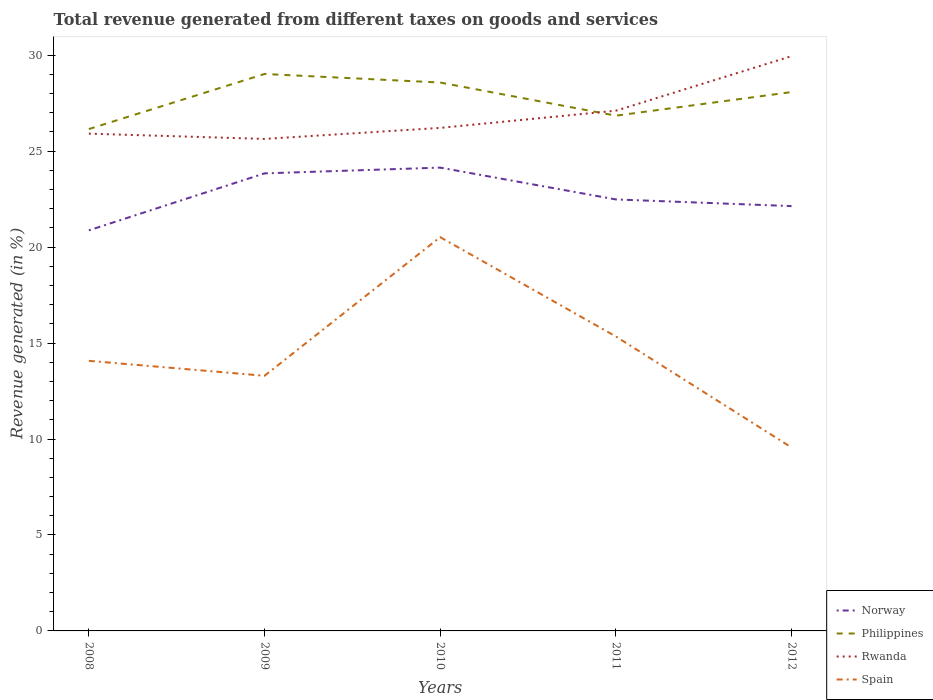Is the number of lines equal to the number of legend labels?
Give a very brief answer. Yes. Across all years, what is the maximum total revenue generated in Norway?
Provide a succinct answer. 20.87. In which year was the total revenue generated in Rwanda maximum?
Ensure brevity in your answer.  2009. What is the total total revenue generated in Norway in the graph?
Your answer should be very brief. -2.97. What is the difference between the highest and the second highest total revenue generated in Philippines?
Ensure brevity in your answer.  2.87. Is the total revenue generated in Philippines strictly greater than the total revenue generated in Rwanda over the years?
Offer a very short reply. No. How many years are there in the graph?
Your answer should be very brief. 5. What is the difference between two consecutive major ticks on the Y-axis?
Give a very brief answer. 5. Does the graph contain grids?
Provide a succinct answer. No. Where does the legend appear in the graph?
Provide a succinct answer. Bottom right. How many legend labels are there?
Make the answer very short. 4. What is the title of the graph?
Offer a terse response. Total revenue generated from different taxes on goods and services. Does "Slovak Republic" appear as one of the legend labels in the graph?
Give a very brief answer. No. What is the label or title of the X-axis?
Offer a terse response. Years. What is the label or title of the Y-axis?
Keep it short and to the point. Revenue generated (in %). What is the Revenue generated (in %) of Norway in 2008?
Your answer should be compact. 20.87. What is the Revenue generated (in %) of Philippines in 2008?
Offer a very short reply. 26.15. What is the Revenue generated (in %) in Rwanda in 2008?
Provide a succinct answer. 25.91. What is the Revenue generated (in %) of Spain in 2008?
Keep it short and to the point. 14.07. What is the Revenue generated (in %) of Norway in 2009?
Ensure brevity in your answer.  23.84. What is the Revenue generated (in %) in Philippines in 2009?
Give a very brief answer. 29.02. What is the Revenue generated (in %) of Rwanda in 2009?
Provide a short and direct response. 25.64. What is the Revenue generated (in %) in Spain in 2009?
Ensure brevity in your answer.  13.3. What is the Revenue generated (in %) of Norway in 2010?
Keep it short and to the point. 24.14. What is the Revenue generated (in %) of Philippines in 2010?
Your answer should be compact. 28.58. What is the Revenue generated (in %) of Rwanda in 2010?
Ensure brevity in your answer.  26.21. What is the Revenue generated (in %) in Spain in 2010?
Offer a very short reply. 20.52. What is the Revenue generated (in %) of Norway in 2011?
Provide a short and direct response. 22.48. What is the Revenue generated (in %) in Philippines in 2011?
Make the answer very short. 26.85. What is the Revenue generated (in %) in Rwanda in 2011?
Ensure brevity in your answer.  27.11. What is the Revenue generated (in %) of Spain in 2011?
Keep it short and to the point. 15.34. What is the Revenue generated (in %) in Norway in 2012?
Your response must be concise. 22.14. What is the Revenue generated (in %) in Philippines in 2012?
Your response must be concise. 28.08. What is the Revenue generated (in %) in Rwanda in 2012?
Offer a very short reply. 29.95. What is the Revenue generated (in %) in Spain in 2012?
Provide a short and direct response. 9.56. Across all years, what is the maximum Revenue generated (in %) of Norway?
Offer a very short reply. 24.14. Across all years, what is the maximum Revenue generated (in %) of Philippines?
Provide a succinct answer. 29.02. Across all years, what is the maximum Revenue generated (in %) in Rwanda?
Ensure brevity in your answer.  29.95. Across all years, what is the maximum Revenue generated (in %) in Spain?
Your answer should be compact. 20.52. Across all years, what is the minimum Revenue generated (in %) in Norway?
Provide a short and direct response. 20.87. Across all years, what is the minimum Revenue generated (in %) in Philippines?
Your response must be concise. 26.15. Across all years, what is the minimum Revenue generated (in %) in Rwanda?
Offer a very short reply. 25.64. Across all years, what is the minimum Revenue generated (in %) in Spain?
Your response must be concise. 9.56. What is the total Revenue generated (in %) in Norway in the graph?
Ensure brevity in your answer.  113.48. What is the total Revenue generated (in %) of Philippines in the graph?
Make the answer very short. 138.68. What is the total Revenue generated (in %) in Rwanda in the graph?
Your answer should be compact. 134.82. What is the total Revenue generated (in %) of Spain in the graph?
Ensure brevity in your answer.  72.79. What is the difference between the Revenue generated (in %) in Norway in 2008 and that in 2009?
Provide a succinct answer. -2.97. What is the difference between the Revenue generated (in %) of Philippines in 2008 and that in 2009?
Make the answer very short. -2.87. What is the difference between the Revenue generated (in %) in Rwanda in 2008 and that in 2009?
Your answer should be very brief. 0.27. What is the difference between the Revenue generated (in %) in Spain in 2008 and that in 2009?
Make the answer very short. 0.78. What is the difference between the Revenue generated (in %) of Norway in 2008 and that in 2010?
Your response must be concise. -3.27. What is the difference between the Revenue generated (in %) in Philippines in 2008 and that in 2010?
Provide a short and direct response. -2.42. What is the difference between the Revenue generated (in %) of Rwanda in 2008 and that in 2010?
Make the answer very short. -0.3. What is the difference between the Revenue generated (in %) in Spain in 2008 and that in 2010?
Give a very brief answer. -6.45. What is the difference between the Revenue generated (in %) in Norway in 2008 and that in 2011?
Make the answer very short. -1.61. What is the difference between the Revenue generated (in %) of Philippines in 2008 and that in 2011?
Offer a terse response. -0.7. What is the difference between the Revenue generated (in %) of Rwanda in 2008 and that in 2011?
Your response must be concise. -1.2. What is the difference between the Revenue generated (in %) in Spain in 2008 and that in 2011?
Keep it short and to the point. -1.27. What is the difference between the Revenue generated (in %) in Norway in 2008 and that in 2012?
Make the answer very short. -1.26. What is the difference between the Revenue generated (in %) of Philippines in 2008 and that in 2012?
Provide a short and direct response. -1.93. What is the difference between the Revenue generated (in %) in Rwanda in 2008 and that in 2012?
Ensure brevity in your answer.  -4.04. What is the difference between the Revenue generated (in %) in Spain in 2008 and that in 2012?
Your answer should be very brief. 4.51. What is the difference between the Revenue generated (in %) in Philippines in 2009 and that in 2010?
Offer a very short reply. 0.45. What is the difference between the Revenue generated (in %) in Rwanda in 2009 and that in 2010?
Your answer should be very brief. -0.57. What is the difference between the Revenue generated (in %) in Spain in 2009 and that in 2010?
Provide a succinct answer. -7.22. What is the difference between the Revenue generated (in %) in Norway in 2009 and that in 2011?
Give a very brief answer. 1.36. What is the difference between the Revenue generated (in %) in Philippines in 2009 and that in 2011?
Keep it short and to the point. 2.17. What is the difference between the Revenue generated (in %) in Rwanda in 2009 and that in 2011?
Give a very brief answer. -1.47. What is the difference between the Revenue generated (in %) in Spain in 2009 and that in 2011?
Offer a terse response. -2.05. What is the difference between the Revenue generated (in %) of Norway in 2009 and that in 2012?
Your answer should be compact. 1.71. What is the difference between the Revenue generated (in %) in Philippines in 2009 and that in 2012?
Offer a very short reply. 0.94. What is the difference between the Revenue generated (in %) in Rwanda in 2009 and that in 2012?
Offer a terse response. -4.31. What is the difference between the Revenue generated (in %) in Spain in 2009 and that in 2012?
Give a very brief answer. 3.74. What is the difference between the Revenue generated (in %) in Norway in 2010 and that in 2011?
Make the answer very short. 1.66. What is the difference between the Revenue generated (in %) of Philippines in 2010 and that in 2011?
Your answer should be compact. 1.73. What is the difference between the Revenue generated (in %) in Rwanda in 2010 and that in 2011?
Offer a terse response. -0.9. What is the difference between the Revenue generated (in %) in Spain in 2010 and that in 2011?
Provide a short and direct response. 5.17. What is the difference between the Revenue generated (in %) in Norway in 2010 and that in 2012?
Provide a short and direct response. 2.01. What is the difference between the Revenue generated (in %) in Philippines in 2010 and that in 2012?
Offer a very short reply. 0.5. What is the difference between the Revenue generated (in %) of Rwanda in 2010 and that in 2012?
Offer a very short reply. -3.74. What is the difference between the Revenue generated (in %) in Spain in 2010 and that in 2012?
Provide a short and direct response. 10.96. What is the difference between the Revenue generated (in %) of Norway in 2011 and that in 2012?
Provide a short and direct response. 0.35. What is the difference between the Revenue generated (in %) in Philippines in 2011 and that in 2012?
Keep it short and to the point. -1.23. What is the difference between the Revenue generated (in %) in Rwanda in 2011 and that in 2012?
Your response must be concise. -2.84. What is the difference between the Revenue generated (in %) in Spain in 2011 and that in 2012?
Give a very brief answer. 5.78. What is the difference between the Revenue generated (in %) in Norway in 2008 and the Revenue generated (in %) in Philippines in 2009?
Your response must be concise. -8.15. What is the difference between the Revenue generated (in %) in Norway in 2008 and the Revenue generated (in %) in Rwanda in 2009?
Offer a terse response. -4.76. What is the difference between the Revenue generated (in %) in Norway in 2008 and the Revenue generated (in %) in Spain in 2009?
Offer a very short reply. 7.58. What is the difference between the Revenue generated (in %) in Philippines in 2008 and the Revenue generated (in %) in Rwanda in 2009?
Your answer should be very brief. 0.51. What is the difference between the Revenue generated (in %) in Philippines in 2008 and the Revenue generated (in %) in Spain in 2009?
Provide a short and direct response. 12.86. What is the difference between the Revenue generated (in %) of Rwanda in 2008 and the Revenue generated (in %) of Spain in 2009?
Provide a succinct answer. 12.62. What is the difference between the Revenue generated (in %) of Norway in 2008 and the Revenue generated (in %) of Philippines in 2010?
Provide a succinct answer. -7.7. What is the difference between the Revenue generated (in %) of Norway in 2008 and the Revenue generated (in %) of Rwanda in 2010?
Provide a short and direct response. -5.34. What is the difference between the Revenue generated (in %) in Norway in 2008 and the Revenue generated (in %) in Spain in 2010?
Provide a succinct answer. 0.36. What is the difference between the Revenue generated (in %) in Philippines in 2008 and the Revenue generated (in %) in Rwanda in 2010?
Offer a terse response. -0.06. What is the difference between the Revenue generated (in %) of Philippines in 2008 and the Revenue generated (in %) of Spain in 2010?
Provide a short and direct response. 5.63. What is the difference between the Revenue generated (in %) of Rwanda in 2008 and the Revenue generated (in %) of Spain in 2010?
Offer a very short reply. 5.39. What is the difference between the Revenue generated (in %) of Norway in 2008 and the Revenue generated (in %) of Philippines in 2011?
Make the answer very short. -5.98. What is the difference between the Revenue generated (in %) in Norway in 2008 and the Revenue generated (in %) in Rwanda in 2011?
Offer a very short reply. -6.23. What is the difference between the Revenue generated (in %) of Norway in 2008 and the Revenue generated (in %) of Spain in 2011?
Give a very brief answer. 5.53. What is the difference between the Revenue generated (in %) of Philippines in 2008 and the Revenue generated (in %) of Rwanda in 2011?
Keep it short and to the point. -0.96. What is the difference between the Revenue generated (in %) in Philippines in 2008 and the Revenue generated (in %) in Spain in 2011?
Your answer should be compact. 10.81. What is the difference between the Revenue generated (in %) in Rwanda in 2008 and the Revenue generated (in %) in Spain in 2011?
Keep it short and to the point. 10.57. What is the difference between the Revenue generated (in %) in Norway in 2008 and the Revenue generated (in %) in Philippines in 2012?
Make the answer very short. -7.21. What is the difference between the Revenue generated (in %) of Norway in 2008 and the Revenue generated (in %) of Rwanda in 2012?
Ensure brevity in your answer.  -9.08. What is the difference between the Revenue generated (in %) in Norway in 2008 and the Revenue generated (in %) in Spain in 2012?
Ensure brevity in your answer.  11.31. What is the difference between the Revenue generated (in %) in Philippines in 2008 and the Revenue generated (in %) in Rwanda in 2012?
Offer a terse response. -3.8. What is the difference between the Revenue generated (in %) of Philippines in 2008 and the Revenue generated (in %) of Spain in 2012?
Make the answer very short. 16.59. What is the difference between the Revenue generated (in %) of Rwanda in 2008 and the Revenue generated (in %) of Spain in 2012?
Your response must be concise. 16.35. What is the difference between the Revenue generated (in %) in Norway in 2009 and the Revenue generated (in %) in Philippines in 2010?
Offer a terse response. -4.73. What is the difference between the Revenue generated (in %) of Norway in 2009 and the Revenue generated (in %) of Rwanda in 2010?
Provide a succinct answer. -2.37. What is the difference between the Revenue generated (in %) in Norway in 2009 and the Revenue generated (in %) in Spain in 2010?
Keep it short and to the point. 3.32. What is the difference between the Revenue generated (in %) in Philippines in 2009 and the Revenue generated (in %) in Rwanda in 2010?
Provide a succinct answer. 2.81. What is the difference between the Revenue generated (in %) in Philippines in 2009 and the Revenue generated (in %) in Spain in 2010?
Provide a short and direct response. 8.5. What is the difference between the Revenue generated (in %) in Rwanda in 2009 and the Revenue generated (in %) in Spain in 2010?
Offer a terse response. 5.12. What is the difference between the Revenue generated (in %) of Norway in 2009 and the Revenue generated (in %) of Philippines in 2011?
Give a very brief answer. -3.01. What is the difference between the Revenue generated (in %) of Norway in 2009 and the Revenue generated (in %) of Rwanda in 2011?
Offer a very short reply. -3.27. What is the difference between the Revenue generated (in %) in Norway in 2009 and the Revenue generated (in %) in Spain in 2011?
Offer a very short reply. 8.5. What is the difference between the Revenue generated (in %) of Philippines in 2009 and the Revenue generated (in %) of Rwanda in 2011?
Ensure brevity in your answer.  1.91. What is the difference between the Revenue generated (in %) of Philippines in 2009 and the Revenue generated (in %) of Spain in 2011?
Offer a very short reply. 13.68. What is the difference between the Revenue generated (in %) in Rwanda in 2009 and the Revenue generated (in %) in Spain in 2011?
Offer a terse response. 10.29. What is the difference between the Revenue generated (in %) of Norway in 2009 and the Revenue generated (in %) of Philippines in 2012?
Your answer should be compact. -4.24. What is the difference between the Revenue generated (in %) of Norway in 2009 and the Revenue generated (in %) of Rwanda in 2012?
Provide a short and direct response. -6.11. What is the difference between the Revenue generated (in %) of Norway in 2009 and the Revenue generated (in %) of Spain in 2012?
Make the answer very short. 14.28. What is the difference between the Revenue generated (in %) in Philippines in 2009 and the Revenue generated (in %) in Rwanda in 2012?
Keep it short and to the point. -0.93. What is the difference between the Revenue generated (in %) of Philippines in 2009 and the Revenue generated (in %) of Spain in 2012?
Your answer should be compact. 19.46. What is the difference between the Revenue generated (in %) of Rwanda in 2009 and the Revenue generated (in %) of Spain in 2012?
Ensure brevity in your answer.  16.08. What is the difference between the Revenue generated (in %) of Norway in 2010 and the Revenue generated (in %) of Philippines in 2011?
Provide a short and direct response. -2.71. What is the difference between the Revenue generated (in %) in Norway in 2010 and the Revenue generated (in %) in Rwanda in 2011?
Make the answer very short. -2.97. What is the difference between the Revenue generated (in %) of Norway in 2010 and the Revenue generated (in %) of Spain in 2011?
Keep it short and to the point. 8.8. What is the difference between the Revenue generated (in %) of Philippines in 2010 and the Revenue generated (in %) of Rwanda in 2011?
Provide a short and direct response. 1.47. What is the difference between the Revenue generated (in %) of Philippines in 2010 and the Revenue generated (in %) of Spain in 2011?
Your response must be concise. 13.23. What is the difference between the Revenue generated (in %) in Rwanda in 2010 and the Revenue generated (in %) in Spain in 2011?
Provide a succinct answer. 10.87. What is the difference between the Revenue generated (in %) of Norway in 2010 and the Revenue generated (in %) of Philippines in 2012?
Your answer should be compact. -3.94. What is the difference between the Revenue generated (in %) in Norway in 2010 and the Revenue generated (in %) in Rwanda in 2012?
Ensure brevity in your answer.  -5.81. What is the difference between the Revenue generated (in %) in Norway in 2010 and the Revenue generated (in %) in Spain in 2012?
Provide a succinct answer. 14.58. What is the difference between the Revenue generated (in %) of Philippines in 2010 and the Revenue generated (in %) of Rwanda in 2012?
Your answer should be compact. -1.38. What is the difference between the Revenue generated (in %) in Philippines in 2010 and the Revenue generated (in %) in Spain in 2012?
Keep it short and to the point. 19.02. What is the difference between the Revenue generated (in %) of Rwanda in 2010 and the Revenue generated (in %) of Spain in 2012?
Give a very brief answer. 16.65. What is the difference between the Revenue generated (in %) of Norway in 2011 and the Revenue generated (in %) of Philippines in 2012?
Provide a succinct answer. -5.59. What is the difference between the Revenue generated (in %) of Norway in 2011 and the Revenue generated (in %) of Rwanda in 2012?
Your answer should be compact. -7.47. What is the difference between the Revenue generated (in %) of Norway in 2011 and the Revenue generated (in %) of Spain in 2012?
Your response must be concise. 12.93. What is the difference between the Revenue generated (in %) in Philippines in 2011 and the Revenue generated (in %) in Rwanda in 2012?
Make the answer very short. -3.1. What is the difference between the Revenue generated (in %) in Philippines in 2011 and the Revenue generated (in %) in Spain in 2012?
Give a very brief answer. 17.29. What is the difference between the Revenue generated (in %) in Rwanda in 2011 and the Revenue generated (in %) in Spain in 2012?
Provide a short and direct response. 17.55. What is the average Revenue generated (in %) in Norway per year?
Your answer should be compact. 22.7. What is the average Revenue generated (in %) of Philippines per year?
Ensure brevity in your answer.  27.74. What is the average Revenue generated (in %) of Rwanda per year?
Ensure brevity in your answer.  26.96. What is the average Revenue generated (in %) in Spain per year?
Ensure brevity in your answer.  14.56. In the year 2008, what is the difference between the Revenue generated (in %) in Norway and Revenue generated (in %) in Philippines?
Provide a succinct answer. -5.28. In the year 2008, what is the difference between the Revenue generated (in %) in Norway and Revenue generated (in %) in Rwanda?
Offer a terse response. -5.04. In the year 2008, what is the difference between the Revenue generated (in %) in Norway and Revenue generated (in %) in Spain?
Keep it short and to the point. 6.8. In the year 2008, what is the difference between the Revenue generated (in %) in Philippines and Revenue generated (in %) in Rwanda?
Provide a succinct answer. 0.24. In the year 2008, what is the difference between the Revenue generated (in %) in Philippines and Revenue generated (in %) in Spain?
Provide a short and direct response. 12.08. In the year 2008, what is the difference between the Revenue generated (in %) of Rwanda and Revenue generated (in %) of Spain?
Give a very brief answer. 11.84. In the year 2009, what is the difference between the Revenue generated (in %) in Norway and Revenue generated (in %) in Philippines?
Give a very brief answer. -5.18. In the year 2009, what is the difference between the Revenue generated (in %) in Norway and Revenue generated (in %) in Rwanda?
Make the answer very short. -1.8. In the year 2009, what is the difference between the Revenue generated (in %) in Norway and Revenue generated (in %) in Spain?
Offer a terse response. 10.55. In the year 2009, what is the difference between the Revenue generated (in %) of Philippines and Revenue generated (in %) of Rwanda?
Provide a short and direct response. 3.38. In the year 2009, what is the difference between the Revenue generated (in %) of Philippines and Revenue generated (in %) of Spain?
Provide a succinct answer. 15.73. In the year 2009, what is the difference between the Revenue generated (in %) of Rwanda and Revenue generated (in %) of Spain?
Your answer should be compact. 12.34. In the year 2010, what is the difference between the Revenue generated (in %) in Norway and Revenue generated (in %) in Philippines?
Provide a succinct answer. -4.43. In the year 2010, what is the difference between the Revenue generated (in %) in Norway and Revenue generated (in %) in Rwanda?
Provide a short and direct response. -2.07. In the year 2010, what is the difference between the Revenue generated (in %) in Norway and Revenue generated (in %) in Spain?
Your answer should be very brief. 3.62. In the year 2010, what is the difference between the Revenue generated (in %) of Philippines and Revenue generated (in %) of Rwanda?
Give a very brief answer. 2.36. In the year 2010, what is the difference between the Revenue generated (in %) in Philippines and Revenue generated (in %) in Spain?
Keep it short and to the point. 8.06. In the year 2010, what is the difference between the Revenue generated (in %) of Rwanda and Revenue generated (in %) of Spain?
Offer a terse response. 5.69. In the year 2011, what is the difference between the Revenue generated (in %) of Norway and Revenue generated (in %) of Philippines?
Provide a short and direct response. -4.36. In the year 2011, what is the difference between the Revenue generated (in %) of Norway and Revenue generated (in %) of Rwanda?
Offer a terse response. -4.62. In the year 2011, what is the difference between the Revenue generated (in %) in Norway and Revenue generated (in %) in Spain?
Ensure brevity in your answer.  7.14. In the year 2011, what is the difference between the Revenue generated (in %) of Philippines and Revenue generated (in %) of Rwanda?
Make the answer very short. -0.26. In the year 2011, what is the difference between the Revenue generated (in %) in Philippines and Revenue generated (in %) in Spain?
Provide a short and direct response. 11.51. In the year 2011, what is the difference between the Revenue generated (in %) in Rwanda and Revenue generated (in %) in Spain?
Your answer should be compact. 11.76. In the year 2012, what is the difference between the Revenue generated (in %) of Norway and Revenue generated (in %) of Philippines?
Ensure brevity in your answer.  -5.94. In the year 2012, what is the difference between the Revenue generated (in %) of Norway and Revenue generated (in %) of Rwanda?
Make the answer very short. -7.81. In the year 2012, what is the difference between the Revenue generated (in %) of Norway and Revenue generated (in %) of Spain?
Keep it short and to the point. 12.58. In the year 2012, what is the difference between the Revenue generated (in %) of Philippines and Revenue generated (in %) of Rwanda?
Your answer should be very brief. -1.87. In the year 2012, what is the difference between the Revenue generated (in %) of Philippines and Revenue generated (in %) of Spain?
Provide a succinct answer. 18.52. In the year 2012, what is the difference between the Revenue generated (in %) of Rwanda and Revenue generated (in %) of Spain?
Provide a succinct answer. 20.39. What is the ratio of the Revenue generated (in %) of Norway in 2008 to that in 2009?
Your answer should be very brief. 0.88. What is the ratio of the Revenue generated (in %) of Philippines in 2008 to that in 2009?
Provide a short and direct response. 0.9. What is the ratio of the Revenue generated (in %) in Rwanda in 2008 to that in 2009?
Give a very brief answer. 1.01. What is the ratio of the Revenue generated (in %) of Spain in 2008 to that in 2009?
Offer a terse response. 1.06. What is the ratio of the Revenue generated (in %) of Norway in 2008 to that in 2010?
Make the answer very short. 0.86. What is the ratio of the Revenue generated (in %) of Philippines in 2008 to that in 2010?
Give a very brief answer. 0.92. What is the ratio of the Revenue generated (in %) in Spain in 2008 to that in 2010?
Make the answer very short. 0.69. What is the ratio of the Revenue generated (in %) in Norway in 2008 to that in 2011?
Provide a short and direct response. 0.93. What is the ratio of the Revenue generated (in %) in Philippines in 2008 to that in 2011?
Give a very brief answer. 0.97. What is the ratio of the Revenue generated (in %) of Rwanda in 2008 to that in 2011?
Keep it short and to the point. 0.96. What is the ratio of the Revenue generated (in %) in Spain in 2008 to that in 2011?
Your response must be concise. 0.92. What is the ratio of the Revenue generated (in %) of Norway in 2008 to that in 2012?
Offer a terse response. 0.94. What is the ratio of the Revenue generated (in %) in Philippines in 2008 to that in 2012?
Give a very brief answer. 0.93. What is the ratio of the Revenue generated (in %) in Rwanda in 2008 to that in 2012?
Provide a succinct answer. 0.87. What is the ratio of the Revenue generated (in %) in Spain in 2008 to that in 2012?
Your answer should be compact. 1.47. What is the ratio of the Revenue generated (in %) of Norway in 2009 to that in 2010?
Make the answer very short. 0.99. What is the ratio of the Revenue generated (in %) in Philippines in 2009 to that in 2010?
Offer a very short reply. 1.02. What is the ratio of the Revenue generated (in %) of Rwanda in 2009 to that in 2010?
Give a very brief answer. 0.98. What is the ratio of the Revenue generated (in %) of Spain in 2009 to that in 2010?
Offer a terse response. 0.65. What is the ratio of the Revenue generated (in %) of Norway in 2009 to that in 2011?
Your answer should be very brief. 1.06. What is the ratio of the Revenue generated (in %) of Philippines in 2009 to that in 2011?
Your answer should be very brief. 1.08. What is the ratio of the Revenue generated (in %) in Rwanda in 2009 to that in 2011?
Offer a very short reply. 0.95. What is the ratio of the Revenue generated (in %) of Spain in 2009 to that in 2011?
Your response must be concise. 0.87. What is the ratio of the Revenue generated (in %) in Norway in 2009 to that in 2012?
Offer a terse response. 1.08. What is the ratio of the Revenue generated (in %) in Philippines in 2009 to that in 2012?
Provide a short and direct response. 1.03. What is the ratio of the Revenue generated (in %) in Rwanda in 2009 to that in 2012?
Offer a terse response. 0.86. What is the ratio of the Revenue generated (in %) of Spain in 2009 to that in 2012?
Offer a very short reply. 1.39. What is the ratio of the Revenue generated (in %) in Norway in 2010 to that in 2011?
Your answer should be compact. 1.07. What is the ratio of the Revenue generated (in %) in Philippines in 2010 to that in 2011?
Ensure brevity in your answer.  1.06. What is the ratio of the Revenue generated (in %) of Rwanda in 2010 to that in 2011?
Keep it short and to the point. 0.97. What is the ratio of the Revenue generated (in %) in Spain in 2010 to that in 2011?
Ensure brevity in your answer.  1.34. What is the ratio of the Revenue generated (in %) of Norway in 2010 to that in 2012?
Offer a terse response. 1.09. What is the ratio of the Revenue generated (in %) in Philippines in 2010 to that in 2012?
Your response must be concise. 1.02. What is the ratio of the Revenue generated (in %) in Rwanda in 2010 to that in 2012?
Provide a short and direct response. 0.88. What is the ratio of the Revenue generated (in %) of Spain in 2010 to that in 2012?
Provide a short and direct response. 2.15. What is the ratio of the Revenue generated (in %) of Norway in 2011 to that in 2012?
Ensure brevity in your answer.  1.02. What is the ratio of the Revenue generated (in %) of Philippines in 2011 to that in 2012?
Keep it short and to the point. 0.96. What is the ratio of the Revenue generated (in %) in Rwanda in 2011 to that in 2012?
Provide a short and direct response. 0.91. What is the ratio of the Revenue generated (in %) of Spain in 2011 to that in 2012?
Ensure brevity in your answer.  1.61. What is the difference between the highest and the second highest Revenue generated (in %) of Norway?
Provide a succinct answer. 0.3. What is the difference between the highest and the second highest Revenue generated (in %) in Philippines?
Keep it short and to the point. 0.45. What is the difference between the highest and the second highest Revenue generated (in %) in Rwanda?
Keep it short and to the point. 2.84. What is the difference between the highest and the second highest Revenue generated (in %) of Spain?
Your answer should be compact. 5.17. What is the difference between the highest and the lowest Revenue generated (in %) in Norway?
Offer a terse response. 3.27. What is the difference between the highest and the lowest Revenue generated (in %) of Philippines?
Your answer should be very brief. 2.87. What is the difference between the highest and the lowest Revenue generated (in %) of Rwanda?
Make the answer very short. 4.31. What is the difference between the highest and the lowest Revenue generated (in %) in Spain?
Your answer should be compact. 10.96. 